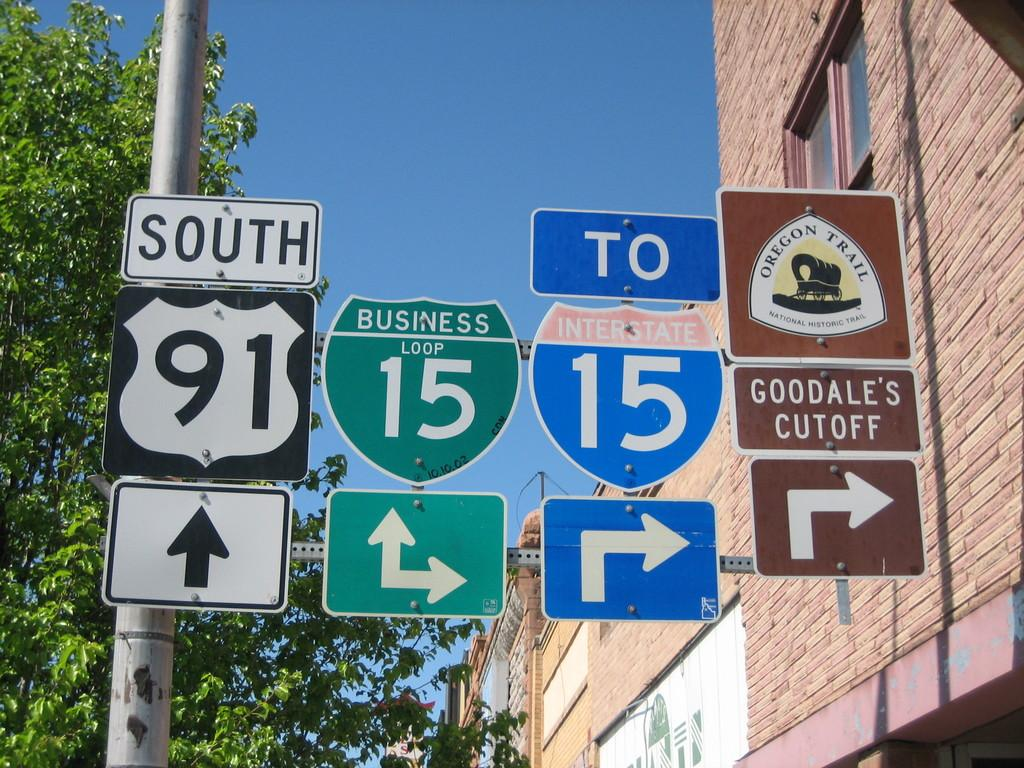<image>
Write a terse but informative summary of the picture. many signs displayed for highways like 91 South and Interstate 15 